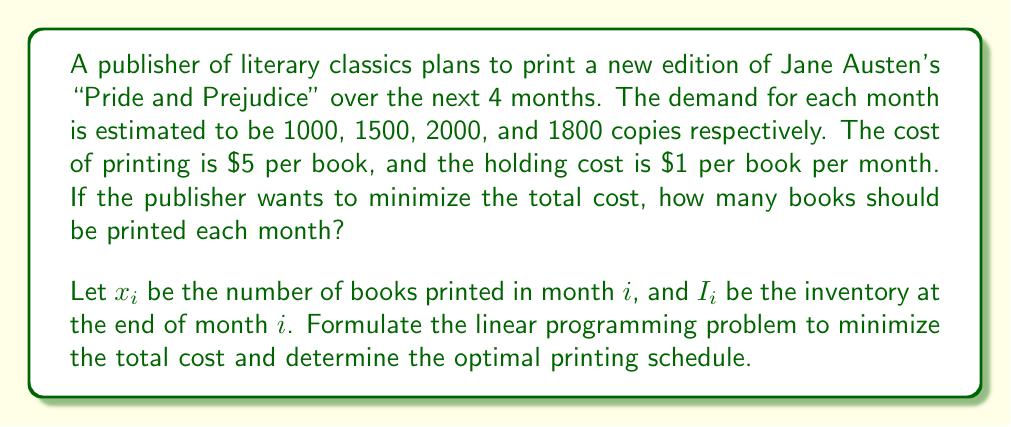Solve this math problem. To solve this problem, we need to set up a linear programming model:

1. Decision variables:
   $x_i$ = number of books printed in month $i$ (for $i = 1, 2, 3, 4$)
   $I_i$ = inventory at the end of month $i$ (for $i = 1, 2, 3, 4$)

2. Objective function:
   Minimize Total Cost = Printing Cost + Holding Cost
   $$\min Z = 5(x_1 + x_2 + x_3 + x_4) + (I_1 + I_2 + I_3 + I_4)$$

3. Constraints:
   a. Inventory balance constraints:
      $$x_1 = 1000 + I_1$$
      $$x_2 + I_1 = 1500 + I_2$$
      $$x_3 + I_2 = 2000 + I_3$$
      $$x_4 + I_3 = 1800 + I_4$$

   b. Non-negativity constraints:
      $$x_i \geq 0, I_i \geq 0 \text{ for } i = 1, 2, 3, 4$$

4. Solving the linear programming problem:
   Using the simplex method or a linear programming solver, we can find the optimal solution:

   $x_1 = 2500, x_2 = 0, x_3 = 2000, x_4 = 1800$
   $I_1 = 1500, I_2 = 0, I_3 = 0, I_4 = 0$

5. Interpretation:
   - Print 2500 books in month 1
   - Print no books in month 2
   - Print 2000 books in month 3
   - Print 1800 books in month 4

This schedule minimizes the total cost by balancing the printing and holding costs. The publisher prints more books in the first month to avoid holding costs in later months, while still meeting the demand for each month.
Answer: The optimal printing schedule is:
Month 1: 2500 books
Month 2: 0 books
Month 3: 2000 books
Month 4: 1800 books 